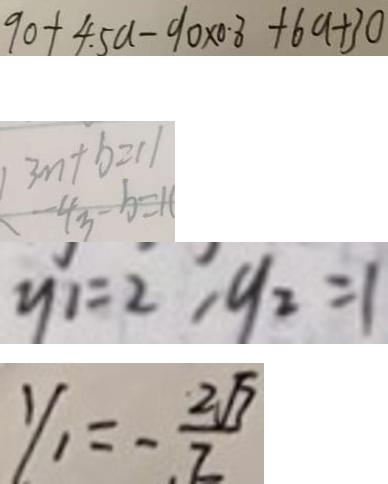<formula> <loc_0><loc_0><loc_500><loc_500>9 0 + 4 . 5 a - 9 0 \times 0 . 8 + 6 a + 3 0 
 3 m + b = 1 1 
 y _ { 1 } = 2 , y _ { 2 } = 1 
 y _ { 1 } = - \frac { 2 \sqrt { 7 } } { 7 }</formula> 